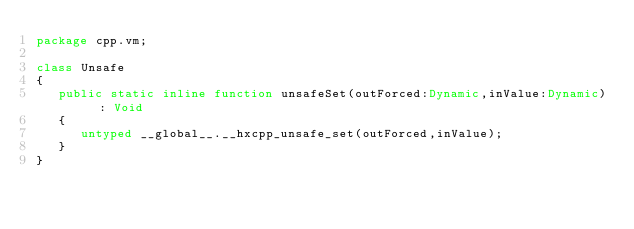Convert code to text. <code><loc_0><loc_0><loc_500><loc_500><_Haxe_>package cpp.vm;

class Unsafe
{
   public static inline function unsafeSet(outForced:Dynamic,inValue:Dynamic) : Void
   {
      untyped __global__.__hxcpp_unsafe_set(outForced,inValue);
   }
}

</code> 